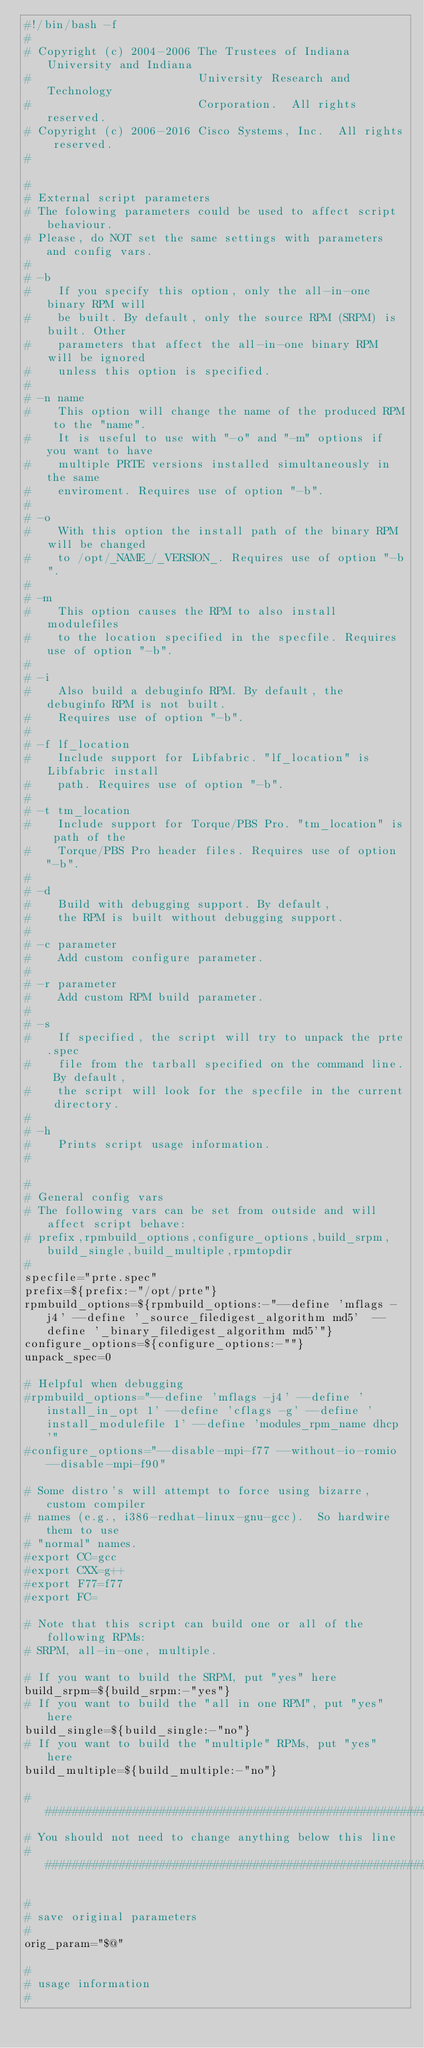<code> <loc_0><loc_0><loc_500><loc_500><_Bash_>#!/bin/bash -f
#
# Copyright (c) 2004-2006 The Trustees of Indiana University and Indiana
#                         University Research and Technology
#                         Corporation.  All rights reserved.
# Copyright (c) 2006-2016 Cisco Systems, Inc.  All rights reserved.
#

#
# External script parameters
# The folowing parameters could be used to affect script behaviour.
# Please, do NOT set the same settings with parameters and config vars.
#
# -b
#    If you specify this option, only the all-in-one binary RPM will
#    be built. By default, only the source RPM (SRPM) is built. Other
#    parameters that affect the all-in-one binary RPM will be ignored
#    unless this option is specified.
#
# -n name
#    This option will change the name of the produced RPM to the "name".
#    It is useful to use with "-o" and "-m" options if you want to have
#    multiple PRTE versions installed simultaneously in the same
#    enviroment. Requires use of option "-b".
#
# -o
#    With this option the install path of the binary RPM will be changed
#    to /opt/_NAME_/_VERSION_. Requires use of option "-b".
#
# -m
#    This option causes the RPM to also install modulefiles
#    to the location specified in the specfile. Requires use of option "-b".
#
# -i
#    Also build a debuginfo RPM. By default, the debuginfo RPM is not built.
#    Requires use of option "-b".
#
# -f lf_location
#    Include support for Libfabric. "lf_location" is Libfabric install
#    path. Requires use of option "-b".
#
# -t tm_location
#    Include support for Torque/PBS Pro. "tm_location" is path of the
#    Torque/PBS Pro header files. Requires use of option "-b".
#
# -d
#    Build with debugging support. By default,
#    the RPM is built without debugging support.
#
# -c parameter
#    Add custom configure parameter.
#
# -r parameter
#    Add custom RPM build parameter.
#
# -s
#    If specified, the script will try to unpack the prte.spec
#    file from the tarball specified on the command line. By default,
#    the script will look for the specfile in the current directory.
#
# -h
#    Prints script usage information.
#

#
# General config vars
# The following vars can be set from outside and will affect script behave:
# prefix,rpmbuild_options,configure_options,build_srpm,build_single,build_multiple,rpmtopdir
#
specfile="prte.spec"
prefix=${prefix:-"/opt/prte"}
rpmbuild_options=${rpmbuild_options:-"--define 'mflags -j4' --define '_source_filedigest_algorithm md5'  --define '_binary_filedigest_algorithm md5'"}
configure_options=${configure_options:-""}
unpack_spec=0

# Helpful when debugging
#rpmbuild_options="--define 'mflags -j4' --define 'install_in_opt 1' --define 'cflags -g' --define 'install_modulefile 1' --define 'modules_rpm_name dhcp'"
#configure_options="--disable-mpi-f77 --without-io-romio --disable-mpi-f90"

# Some distro's will attempt to force using bizarre, custom compiler
# names (e.g., i386-redhat-linux-gnu-gcc).  So hardwire them to use
# "normal" names.
#export CC=gcc
#export CXX=g++
#export F77=f77
#export FC=

# Note that this script can build one or all of the following RPMs:
# SRPM, all-in-one, multiple.

# If you want to build the SRPM, put "yes" here
build_srpm=${build_srpm:-"yes"}
# If you want to build the "all in one RPM", put "yes" here
build_single=${build_single:-"no"}
# If you want to build the "multiple" RPMs, put "yes" here
build_multiple=${build_multiple:-"no"}

#########################################################################
# You should not need to change anything below this line
#########################################################################

#
# save original parameters
#
orig_param="$@"

#
# usage information
#</code> 